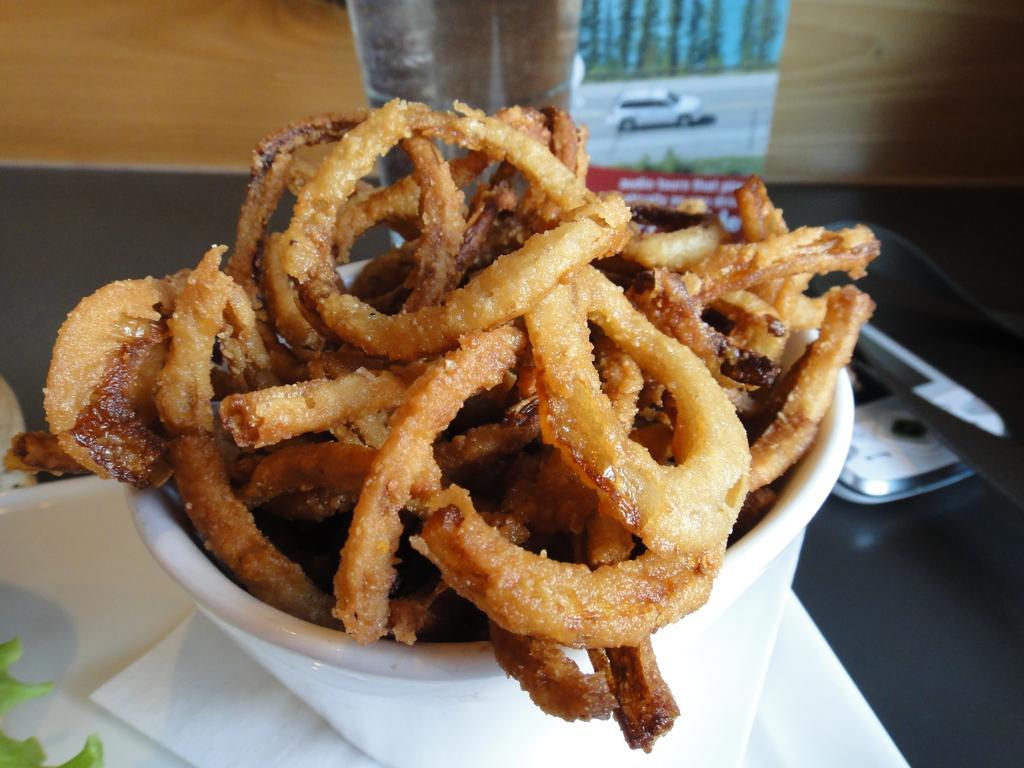Can you describe this image briefly? In this image we can see some different food, different objects on the table and one poster. In that poster there are so many trees, grass and car on the road. 